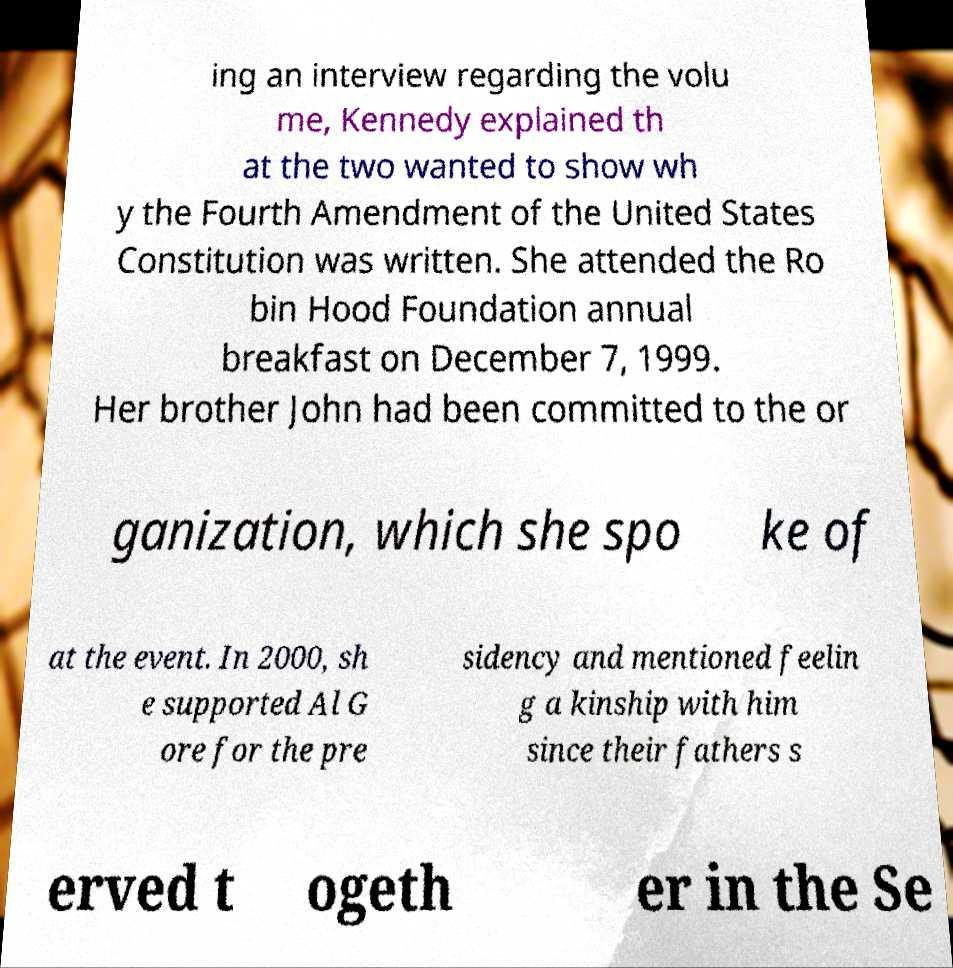What messages or text are displayed in this image? I need them in a readable, typed format. ing an interview regarding the volu me, Kennedy explained th at the two wanted to show wh y the Fourth Amendment of the United States Constitution was written. She attended the Ro bin Hood Foundation annual breakfast on December 7, 1999. Her brother John had been committed to the or ganization, which she spo ke of at the event. In 2000, sh e supported Al G ore for the pre sidency and mentioned feelin g a kinship with him since their fathers s erved t ogeth er in the Se 